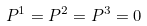Convert formula to latex. <formula><loc_0><loc_0><loc_500><loc_500>P ^ { 1 } = P ^ { 2 } = P ^ { 3 } = 0</formula> 